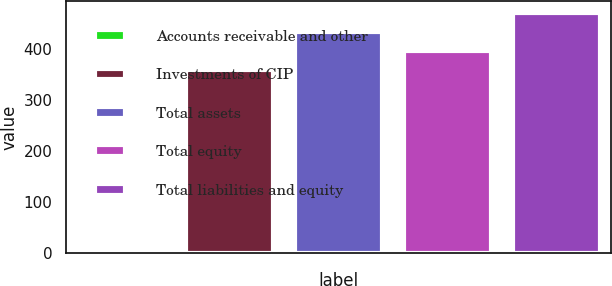Convert chart to OTSL. <chart><loc_0><loc_0><loc_500><loc_500><bar_chart><fcel>Accounts receivable and other<fcel>Investments of CIP<fcel>Total assets<fcel>Total equity<fcel>Total liabilities and equity<nl><fcel>4.1<fcel>358.1<fcel>432.88<fcel>395.49<fcel>470.27<nl></chart> 